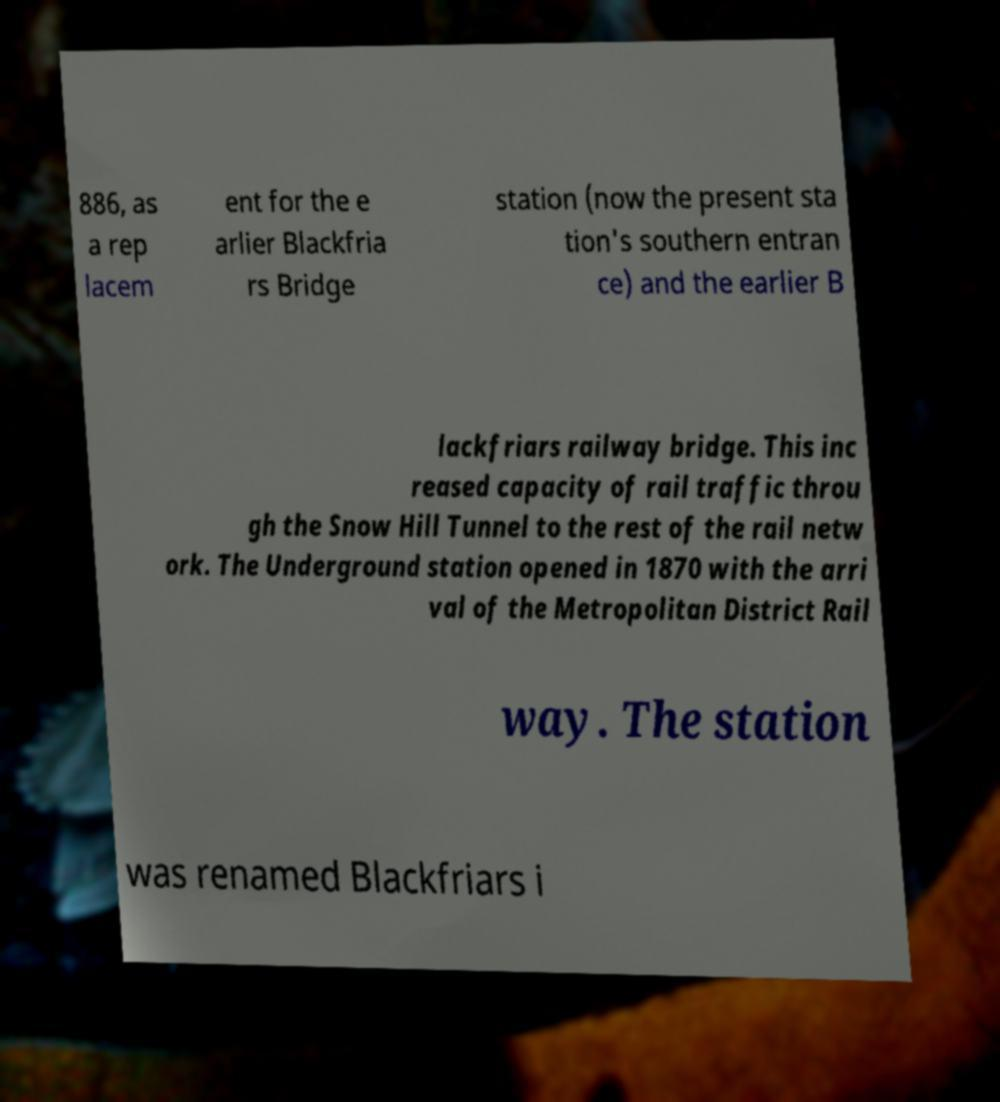What messages or text are displayed in this image? I need them in a readable, typed format. 886, as a rep lacem ent for the e arlier Blackfria rs Bridge station (now the present sta tion's southern entran ce) and the earlier B lackfriars railway bridge. This inc reased capacity of rail traffic throu gh the Snow Hill Tunnel to the rest of the rail netw ork. The Underground station opened in 1870 with the arri val of the Metropolitan District Rail way. The station was renamed Blackfriars i 